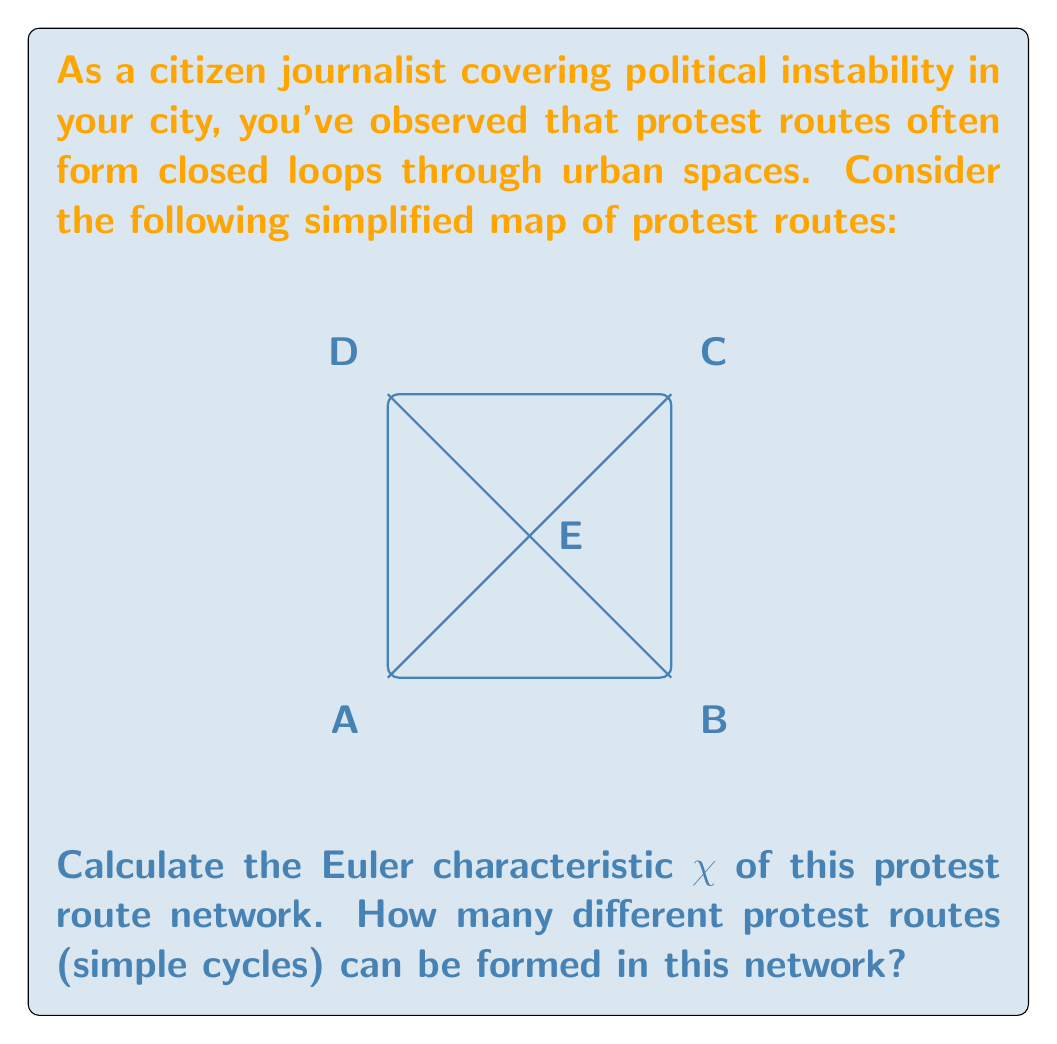Can you solve this math problem? To solve this problem, we'll use concepts from graph theory and topology:

1. First, let's identify the components of the graph:
   - Vertices (V): 5 (A, B, C, D, E)
   - Edges (E): 8 (AB, BC, CD, DA, AE, CE, BE, DE)
   - Faces (F): 5 (including the outer face)

2. Calculate the Euler characteristic:
   $\chi = V - E + F = 5 - 8 + 5 = 2$

3. To find the number of simple cycles, we'll use the cycle basis theorem. The number of independent cycles in a planar graph is given by:
   $\text{Number of cycles} = E - V + 1 = 8 - 5 + 1 = 4$

4. We can verify this by identifying the cycles:
   - ABCDA (outer cycle)
   - ABE
   - BCE
   - CDE

Therefore, there are 4 different protest routes (simple cycles) that can be formed in this network.
Answer: $\chi = 2$; 4 protest routes 